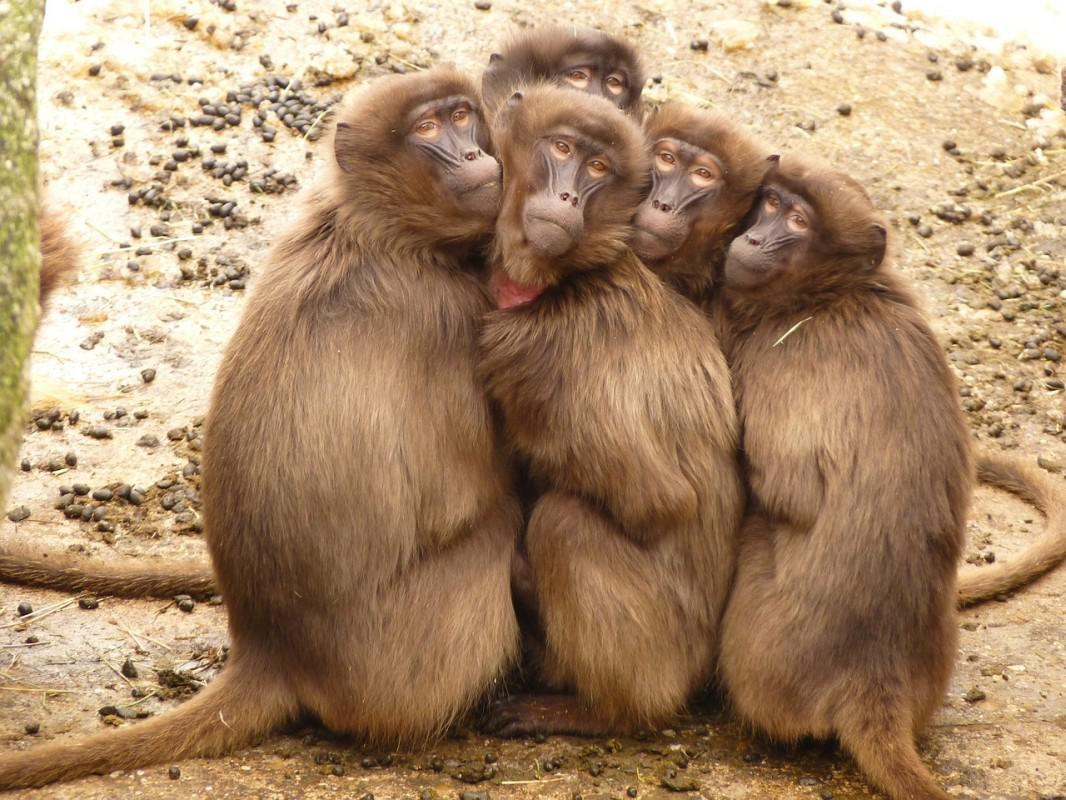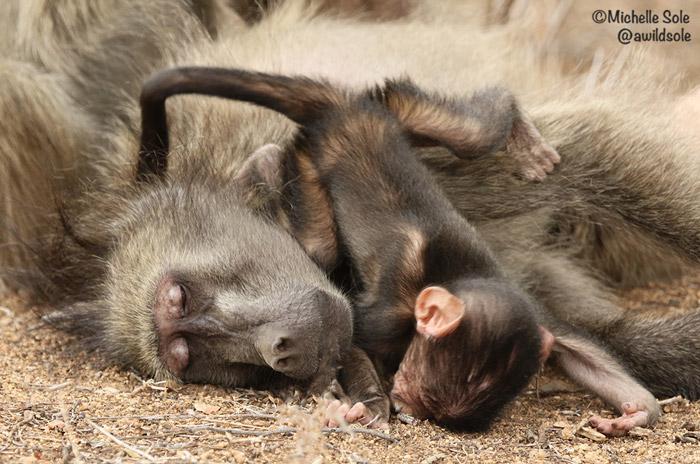The first image is the image on the left, the second image is the image on the right. Evaluate the accuracy of this statement regarding the images: "There is no more than one baboon in the left image.". Is it true? Answer yes or no. No. 